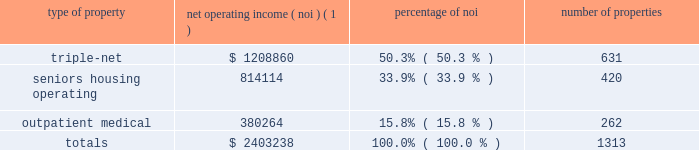Item 7 .
Management 2019s discussion and analysis of financial condition and results of operations the following discussion and analysis is based primarily on the consolidated financial statements of welltower inc .
For the periods presented and should be read together with the notes thereto contained in this annual report on form 10-k .
Other important factors are identified in 201citem 1 2014 business 201d and 201citem 1a 2014 risk factors 201d above .
Executive summary company overview welltower inc .
( nyse : hcn ) , an s&p 500 company headquartered in toledo , ohio , is driving the transformation of health care infrastructure .
The company invests with leading seniors housing operators , post- acute providers and health systems to fund the real estate and infrastructure needed to scale innovative care delivery models and improve people 2019s wellness and overall health care experience .
Welltowertm , a real estate investment trust ( 201creit 201d ) , owns interests in properties concentrated in major , high-growth markets in the united states , canada and the united kingdom , consisting of seniors housing and post-acute communities and outpatient medical properties .
Our capital programs , when combined with comprehensive planning , development and property management services , make us a single-source solution for acquiring , planning , developing , managing , repositioning and monetizing real estate assets .
The table summarizes our consolidated portfolio for the year ended december 31 , 2016 ( dollars in thousands ) : type of property net operating income ( noi ) ( 1 ) percentage of number of properties .
( 1 ) excludes our share of investments in unconsolidated entities and non-segment/corporate noi .
Entities in which we have a joint venture with a minority partner are shown at 100% ( 100 % ) of the joint venture amount .
Business strategy our primary objectives are to protect stockholder capital and enhance stockholder value .
We seek to pay consistent cash dividends to stockholders and create opportunities to increase dividend payments to stockholders as a result of annual increases in net operating income and portfolio growth .
To meet these objectives , we invest across the full spectrum of seniors housing and health care real estate and diversify our investment portfolio by property type , relationship and geographic location .
Substantially all of our revenues are derived from operating lease rentals , resident fees and services , and interest earned on outstanding loans receivable .
These items represent our primary sources of liquidity to fund distributions and depend upon the continued ability of our obligors to make contractual rent and interest payments to us and the profitability of our operating properties .
To the extent that our customers/partners experience operating difficulties and become unable to generate sufficient cash to make payments to us , there could be a material adverse impact on our consolidated results of operations , liquidity and/or financial condition .
To mitigate this risk , we monitor our investments through a variety of methods determined by the type of property .
Our proactive and comprehensive asset management process for seniors housing properties generally includes review of monthly financial statements and other operating data for each property , review of obligor/ partner creditworthiness , property inspections , and review of covenant compliance relating to licensure , real estate taxes , letters of credit and other collateral .
Our internal property management division actively manages and monitors the outpatient medical portfolio with a comprehensive process including review of tenant relations , lease expirations , the mix of health service providers , hospital/health system relationships , property performance .
What was net operating income in millions attributable to triple-net and seniors housing? 
Computations: (1208860 + 814114)
Answer: 2022974.0. 